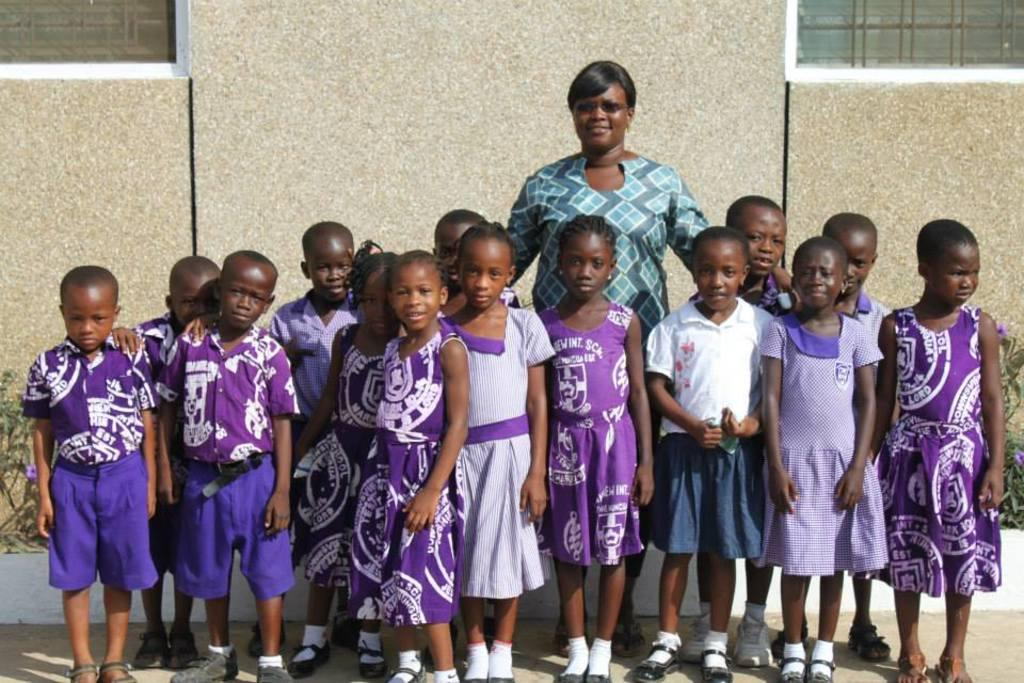How many people are in the image? There is a group of people in the image, but the exact number is not specified. What are the people in the image doing? The people are standing in the image. What can be seen in the background of the image? There is a wall, plants, and metal rods visible in the background of the image. What type of root can be seen growing from the wall in the image? There is no root visible in the image; only a wall, plants, and metal rods are present in the background. What is the cause of the people standing in the image? The cause of the people standing in the image is not mentioned or implied in the image itself. 